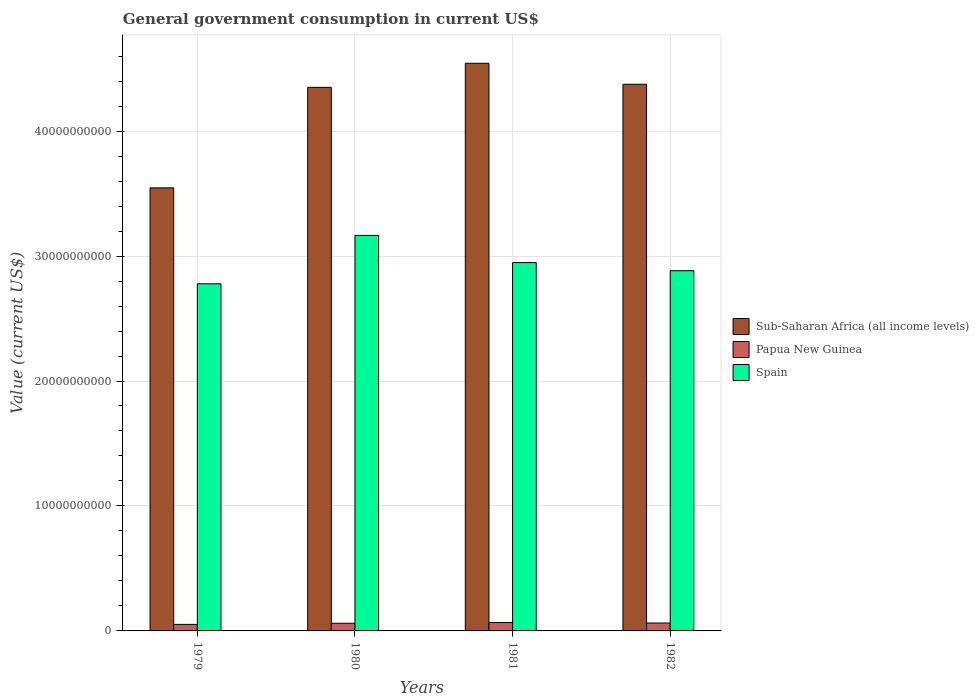How many different coloured bars are there?
Make the answer very short. 3. How many groups of bars are there?
Your answer should be compact. 4. Are the number of bars on each tick of the X-axis equal?
Give a very brief answer. Yes. How many bars are there on the 1st tick from the left?
Your answer should be very brief. 3. How many bars are there on the 4th tick from the right?
Make the answer very short. 3. What is the government conusmption in Papua New Guinea in 1980?
Provide a succinct answer. 6.13e+08. Across all years, what is the maximum government conusmption in Sub-Saharan Africa (all income levels)?
Ensure brevity in your answer.  4.54e+1. Across all years, what is the minimum government conusmption in Spain?
Your answer should be very brief. 2.78e+1. In which year was the government conusmption in Papua New Guinea maximum?
Offer a terse response. 1981. In which year was the government conusmption in Papua New Guinea minimum?
Your response must be concise. 1979. What is the total government conusmption in Spain in the graph?
Your answer should be very brief. 1.18e+11. What is the difference between the government conusmption in Spain in 1980 and that in 1981?
Provide a short and direct response. 2.18e+09. What is the difference between the government conusmption in Sub-Saharan Africa (all income levels) in 1981 and the government conusmption in Papua New Guinea in 1980?
Make the answer very short. 4.48e+1. What is the average government conusmption in Spain per year?
Your answer should be compact. 2.94e+1. In the year 1980, what is the difference between the government conusmption in Papua New Guinea and government conusmption in Spain?
Keep it short and to the point. -3.10e+1. In how many years, is the government conusmption in Papua New Guinea greater than 28000000000 US$?
Make the answer very short. 0. What is the ratio of the government conusmption in Papua New Guinea in 1979 to that in 1980?
Ensure brevity in your answer.  0.85. Is the difference between the government conusmption in Papua New Guinea in 1979 and 1980 greater than the difference between the government conusmption in Spain in 1979 and 1980?
Provide a short and direct response. Yes. What is the difference between the highest and the second highest government conusmption in Papua New Guinea?
Ensure brevity in your answer.  4.13e+07. What is the difference between the highest and the lowest government conusmption in Sub-Saharan Africa (all income levels)?
Your response must be concise. 9.97e+09. Is the sum of the government conusmption in Sub-Saharan Africa (all income levels) in 1979 and 1980 greater than the maximum government conusmption in Papua New Guinea across all years?
Offer a very short reply. Yes. What does the 2nd bar from the left in 1979 represents?
Keep it short and to the point. Papua New Guinea. What does the 2nd bar from the right in 1979 represents?
Make the answer very short. Papua New Guinea. Are all the bars in the graph horizontal?
Ensure brevity in your answer.  No. What is the difference between two consecutive major ticks on the Y-axis?
Ensure brevity in your answer.  1.00e+1. Does the graph contain any zero values?
Offer a terse response. No. Where does the legend appear in the graph?
Your answer should be compact. Center right. How are the legend labels stacked?
Give a very brief answer. Vertical. What is the title of the graph?
Your response must be concise. General government consumption in current US$. What is the label or title of the Y-axis?
Ensure brevity in your answer.  Value (current US$). What is the Value (current US$) of Sub-Saharan Africa (all income levels) in 1979?
Your response must be concise. 3.55e+1. What is the Value (current US$) in Papua New Guinea in 1979?
Your response must be concise. 5.22e+08. What is the Value (current US$) in Spain in 1979?
Give a very brief answer. 2.78e+1. What is the Value (current US$) of Sub-Saharan Africa (all income levels) in 1980?
Provide a short and direct response. 4.35e+1. What is the Value (current US$) in Papua New Guinea in 1980?
Keep it short and to the point. 6.13e+08. What is the Value (current US$) in Spain in 1980?
Your answer should be very brief. 3.17e+1. What is the Value (current US$) of Sub-Saharan Africa (all income levels) in 1981?
Keep it short and to the point. 4.54e+1. What is the Value (current US$) in Papua New Guinea in 1981?
Your answer should be compact. 6.75e+08. What is the Value (current US$) in Spain in 1981?
Keep it short and to the point. 2.95e+1. What is the Value (current US$) of Sub-Saharan Africa (all income levels) in 1982?
Offer a terse response. 4.37e+1. What is the Value (current US$) of Papua New Guinea in 1982?
Give a very brief answer. 6.34e+08. What is the Value (current US$) in Spain in 1982?
Your response must be concise. 2.88e+1. Across all years, what is the maximum Value (current US$) of Sub-Saharan Africa (all income levels)?
Ensure brevity in your answer.  4.54e+1. Across all years, what is the maximum Value (current US$) of Papua New Guinea?
Make the answer very short. 6.75e+08. Across all years, what is the maximum Value (current US$) in Spain?
Your answer should be compact. 3.17e+1. Across all years, what is the minimum Value (current US$) of Sub-Saharan Africa (all income levels)?
Ensure brevity in your answer.  3.55e+1. Across all years, what is the minimum Value (current US$) in Papua New Guinea?
Make the answer very short. 5.22e+08. Across all years, what is the minimum Value (current US$) in Spain?
Offer a terse response. 2.78e+1. What is the total Value (current US$) of Sub-Saharan Africa (all income levels) in the graph?
Provide a succinct answer. 1.68e+11. What is the total Value (current US$) of Papua New Guinea in the graph?
Your response must be concise. 2.44e+09. What is the total Value (current US$) of Spain in the graph?
Offer a very short reply. 1.18e+11. What is the difference between the Value (current US$) in Sub-Saharan Africa (all income levels) in 1979 and that in 1980?
Make the answer very short. -8.04e+09. What is the difference between the Value (current US$) of Papua New Guinea in 1979 and that in 1980?
Your answer should be compact. -9.11e+07. What is the difference between the Value (current US$) in Spain in 1979 and that in 1980?
Provide a short and direct response. -3.87e+09. What is the difference between the Value (current US$) of Sub-Saharan Africa (all income levels) in 1979 and that in 1981?
Provide a short and direct response. -9.97e+09. What is the difference between the Value (current US$) in Papua New Guinea in 1979 and that in 1981?
Your answer should be compact. -1.53e+08. What is the difference between the Value (current US$) of Spain in 1979 and that in 1981?
Offer a very short reply. -1.69e+09. What is the difference between the Value (current US$) in Sub-Saharan Africa (all income levels) in 1979 and that in 1982?
Provide a short and direct response. -8.29e+09. What is the difference between the Value (current US$) in Papua New Guinea in 1979 and that in 1982?
Offer a very short reply. -1.12e+08. What is the difference between the Value (current US$) in Spain in 1979 and that in 1982?
Give a very brief answer. -1.05e+09. What is the difference between the Value (current US$) in Sub-Saharan Africa (all income levels) in 1980 and that in 1981?
Provide a succinct answer. -1.93e+09. What is the difference between the Value (current US$) in Papua New Guinea in 1980 and that in 1981?
Your response must be concise. -6.23e+07. What is the difference between the Value (current US$) in Spain in 1980 and that in 1981?
Make the answer very short. 2.18e+09. What is the difference between the Value (current US$) in Sub-Saharan Africa (all income levels) in 1980 and that in 1982?
Ensure brevity in your answer.  -2.48e+08. What is the difference between the Value (current US$) in Papua New Guinea in 1980 and that in 1982?
Provide a succinct answer. -2.09e+07. What is the difference between the Value (current US$) of Spain in 1980 and that in 1982?
Provide a short and direct response. 2.82e+09. What is the difference between the Value (current US$) in Sub-Saharan Africa (all income levels) in 1981 and that in 1982?
Your answer should be very brief. 1.68e+09. What is the difference between the Value (current US$) in Papua New Guinea in 1981 and that in 1982?
Provide a short and direct response. 4.13e+07. What is the difference between the Value (current US$) of Spain in 1981 and that in 1982?
Ensure brevity in your answer.  6.48e+08. What is the difference between the Value (current US$) of Sub-Saharan Africa (all income levels) in 1979 and the Value (current US$) of Papua New Guinea in 1980?
Make the answer very short. 3.48e+1. What is the difference between the Value (current US$) of Sub-Saharan Africa (all income levels) in 1979 and the Value (current US$) of Spain in 1980?
Provide a short and direct response. 3.80e+09. What is the difference between the Value (current US$) in Papua New Guinea in 1979 and the Value (current US$) in Spain in 1980?
Your answer should be very brief. -3.11e+1. What is the difference between the Value (current US$) in Sub-Saharan Africa (all income levels) in 1979 and the Value (current US$) in Papua New Guinea in 1981?
Offer a terse response. 3.48e+1. What is the difference between the Value (current US$) in Sub-Saharan Africa (all income levels) in 1979 and the Value (current US$) in Spain in 1981?
Your answer should be very brief. 5.98e+09. What is the difference between the Value (current US$) in Papua New Guinea in 1979 and the Value (current US$) in Spain in 1981?
Your response must be concise. -2.90e+1. What is the difference between the Value (current US$) of Sub-Saharan Africa (all income levels) in 1979 and the Value (current US$) of Papua New Guinea in 1982?
Make the answer very short. 3.48e+1. What is the difference between the Value (current US$) in Sub-Saharan Africa (all income levels) in 1979 and the Value (current US$) in Spain in 1982?
Make the answer very short. 6.63e+09. What is the difference between the Value (current US$) in Papua New Guinea in 1979 and the Value (current US$) in Spain in 1982?
Offer a very short reply. -2.83e+1. What is the difference between the Value (current US$) of Sub-Saharan Africa (all income levels) in 1980 and the Value (current US$) of Papua New Guinea in 1981?
Your response must be concise. 4.28e+1. What is the difference between the Value (current US$) of Sub-Saharan Africa (all income levels) in 1980 and the Value (current US$) of Spain in 1981?
Make the answer very short. 1.40e+1. What is the difference between the Value (current US$) of Papua New Guinea in 1980 and the Value (current US$) of Spain in 1981?
Ensure brevity in your answer.  -2.89e+1. What is the difference between the Value (current US$) in Sub-Saharan Africa (all income levels) in 1980 and the Value (current US$) in Papua New Guinea in 1982?
Provide a succinct answer. 4.29e+1. What is the difference between the Value (current US$) of Sub-Saharan Africa (all income levels) in 1980 and the Value (current US$) of Spain in 1982?
Offer a terse response. 1.47e+1. What is the difference between the Value (current US$) of Papua New Guinea in 1980 and the Value (current US$) of Spain in 1982?
Make the answer very short. -2.82e+1. What is the difference between the Value (current US$) in Sub-Saharan Africa (all income levels) in 1981 and the Value (current US$) in Papua New Guinea in 1982?
Provide a succinct answer. 4.48e+1. What is the difference between the Value (current US$) of Sub-Saharan Africa (all income levels) in 1981 and the Value (current US$) of Spain in 1982?
Provide a succinct answer. 1.66e+1. What is the difference between the Value (current US$) in Papua New Guinea in 1981 and the Value (current US$) in Spain in 1982?
Offer a very short reply. -2.82e+1. What is the average Value (current US$) in Sub-Saharan Africa (all income levels) per year?
Provide a succinct answer. 4.20e+1. What is the average Value (current US$) of Papua New Guinea per year?
Your answer should be very brief. 6.11e+08. What is the average Value (current US$) in Spain per year?
Provide a short and direct response. 2.94e+1. In the year 1979, what is the difference between the Value (current US$) of Sub-Saharan Africa (all income levels) and Value (current US$) of Papua New Guinea?
Provide a succinct answer. 3.49e+1. In the year 1979, what is the difference between the Value (current US$) in Sub-Saharan Africa (all income levels) and Value (current US$) in Spain?
Provide a succinct answer. 7.68e+09. In the year 1979, what is the difference between the Value (current US$) of Papua New Guinea and Value (current US$) of Spain?
Provide a succinct answer. -2.73e+1. In the year 1980, what is the difference between the Value (current US$) of Sub-Saharan Africa (all income levels) and Value (current US$) of Papua New Guinea?
Provide a short and direct response. 4.29e+1. In the year 1980, what is the difference between the Value (current US$) of Sub-Saharan Africa (all income levels) and Value (current US$) of Spain?
Keep it short and to the point. 1.18e+1. In the year 1980, what is the difference between the Value (current US$) in Papua New Guinea and Value (current US$) in Spain?
Your answer should be very brief. -3.10e+1. In the year 1981, what is the difference between the Value (current US$) of Sub-Saharan Africa (all income levels) and Value (current US$) of Papua New Guinea?
Keep it short and to the point. 4.48e+1. In the year 1981, what is the difference between the Value (current US$) in Sub-Saharan Africa (all income levels) and Value (current US$) in Spain?
Provide a succinct answer. 1.60e+1. In the year 1981, what is the difference between the Value (current US$) in Papua New Guinea and Value (current US$) in Spain?
Your answer should be very brief. -2.88e+1. In the year 1982, what is the difference between the Value (current US$) of Sub-Saharan Africa (all income levels) and Value (current US$) of Papua New Guinea?
Your answer should be very brief. 4.31e+1. In the year 1982, what is the difference between the Value (current US$) in Sub-Saharan Africa (all income levels) and Value (current US$) in Spain?
Your response must be concise. 1.49e+1. In the year 1982, what is the difference between the Value (current US$) in Papua New Guinea and Value (current US$) in Spain?
Ensure brevity in your answer.  -2.82e+1. What is the ratio of the Value (current US$) of Sub-Saharan Africa (all income levels) in 1979 to that in 1980?
Offer a very short reply. 0.82. What is the ratio of the Value (current US$) of Papua New Guinea in 1979 to that in 1980?
Ensure brevity in your answer.  0.85. What is the ratio of the Value (current US$) in Spain in 1979 to that in 1980?
Make the answer very short. 0.88. What is the ratio of the Value (current US$) in Sub-Saharan Africa (all income levels) in 1979 to that in 1981?
Your answer should be very brief. 0.78. What is the ratio of the Value (current US$) in Papua New Guinea in 1979 to that in 1981?
Give a very brief answer. 0.77. What is the ratio of the Value (current US$) of Spain in 1979 to that in 1981?
Give a very brief answer. 0.94. What is the ratio of the Value (current US$) in Sub-Saharan Africa (all income levels) in 1979 to that in 1982?
Offer a very short reply. 0.81. What is the ratio of the Value (current US$) in Papua New Guinea in 1979 to that in 1982?
Offer a terse response. 0.82. What is the ratio of the Value (current US$) of Spain in 1979 to that in 1982?
Make the answer very short. 0.96. What is the ratio of the Value (current US$) in Sub-Saharan Africa (all income levels) in 1980 to that in 1981?
Offer a very short reply. 0.96. What is the ratio of the Value (current US$) in Papua New Guinea in 1980 to that in 1981?
Offer a terse response. 0.91. What is the ratio of the Value (current US$) of Spain in 1980 to that in 1981?
Provide a succinct answer. 1.07. What is the ratio of the Value (current US$) in Sub-Saharan Africa (all income levels) in 1980 to that in 1982?
Give a very brief answer. 0.99. What is the ratio of the Value (current US$) in Papua New Guinea in 1980 to that in 1982?
Provide a succinct answer. 0.97. What is the ratio of the Value (current US$) of Spain in 1980 to that in 1982?
Offer a terse response. 1.1. What is the ratio of the Value (current US$) of Sub-Saharan Africa (all income levels) in 1981 to that in 1982?
Your response must be concise. 1.04. What is the ratio of the Value (current US$) in Papua New Guinea in 1981 to that in 1982?
Provide a succinct answer. 1.07. What is the ratio of the Value (current US$) in Spain in 1981 to that in 1982?
Your answer should be very brief. 1.02. What is the difference between the highest and the second highest Value (current US$) in Sub-Saharan Africa (all income levels)?
Give a very brief answer. 1.68e+09. What is the difference between the highest and the second highest Value (current US$) in Papua New Guinea?
Your answer should be compact. 4.13e+07. What is the difference between the highest and the second highest Value (current US$) of Spain?
Your answer should be very brief. 2.18e+09. What is the difference between the highest and the lowest Value (current US$) in Sub-Saharan Africa (all income levels)?
Offer a terse response. 9.97e+09. What is the difference between the highest and the lowest Value (current US$) of Papua New Guinea?
Offer a very short reply. 1.53e+08. What is the difference between the highest and the lowest Value (current US$) in Spain?
Ensure brevity in your answer.  3.87e+09. 